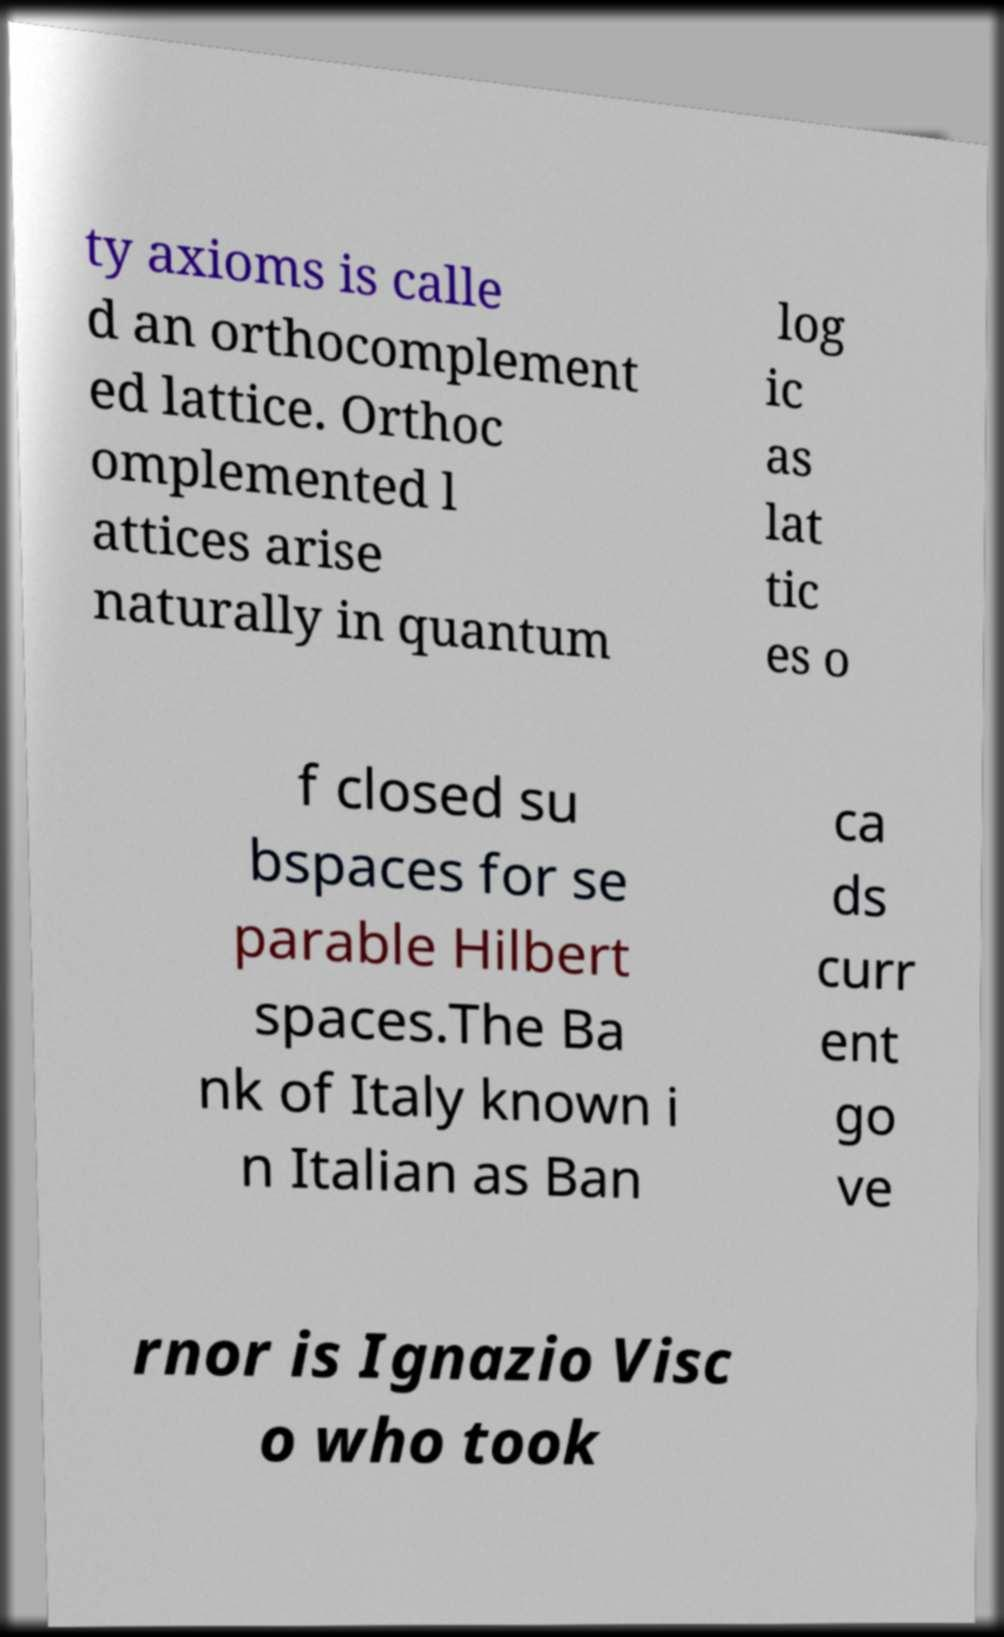Please read and relay the text visible in this image. What does it say? ty axioms is calle d an orthocomplement ed lattice. Orthoc omplemented l attices arise naturally in quantum log ic as lat tic es o f closed su bspaces for se parable Hilbert spaces.The Ba nk of Italy known i n Italian as Ban ca ds curr ent go ve rnor is Ignazio Visc o who took 